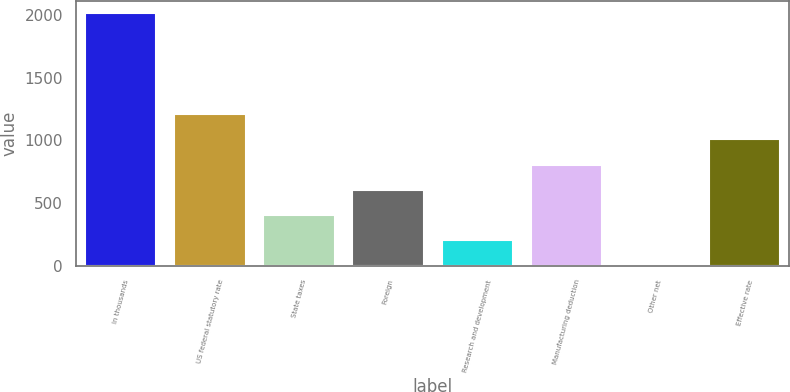Convert chart. <chart><loc_0><loc_0><loc_500><loc_500><bar_chart><fcel>In thousands<fcel>US federal statutory rate<fcel>State taxes<fcel>Foreign<fcel>Research and development<fcel>Manufacturing deduction<fcel>Other net<fcel>Effective rate<nl><fcel>2015<fcel>1209.04<fcel>403.08<fcel>604.57<fcel>201.59<fcel>806.06<fcel>0.1<fcel>1007.55<nl></chart> 